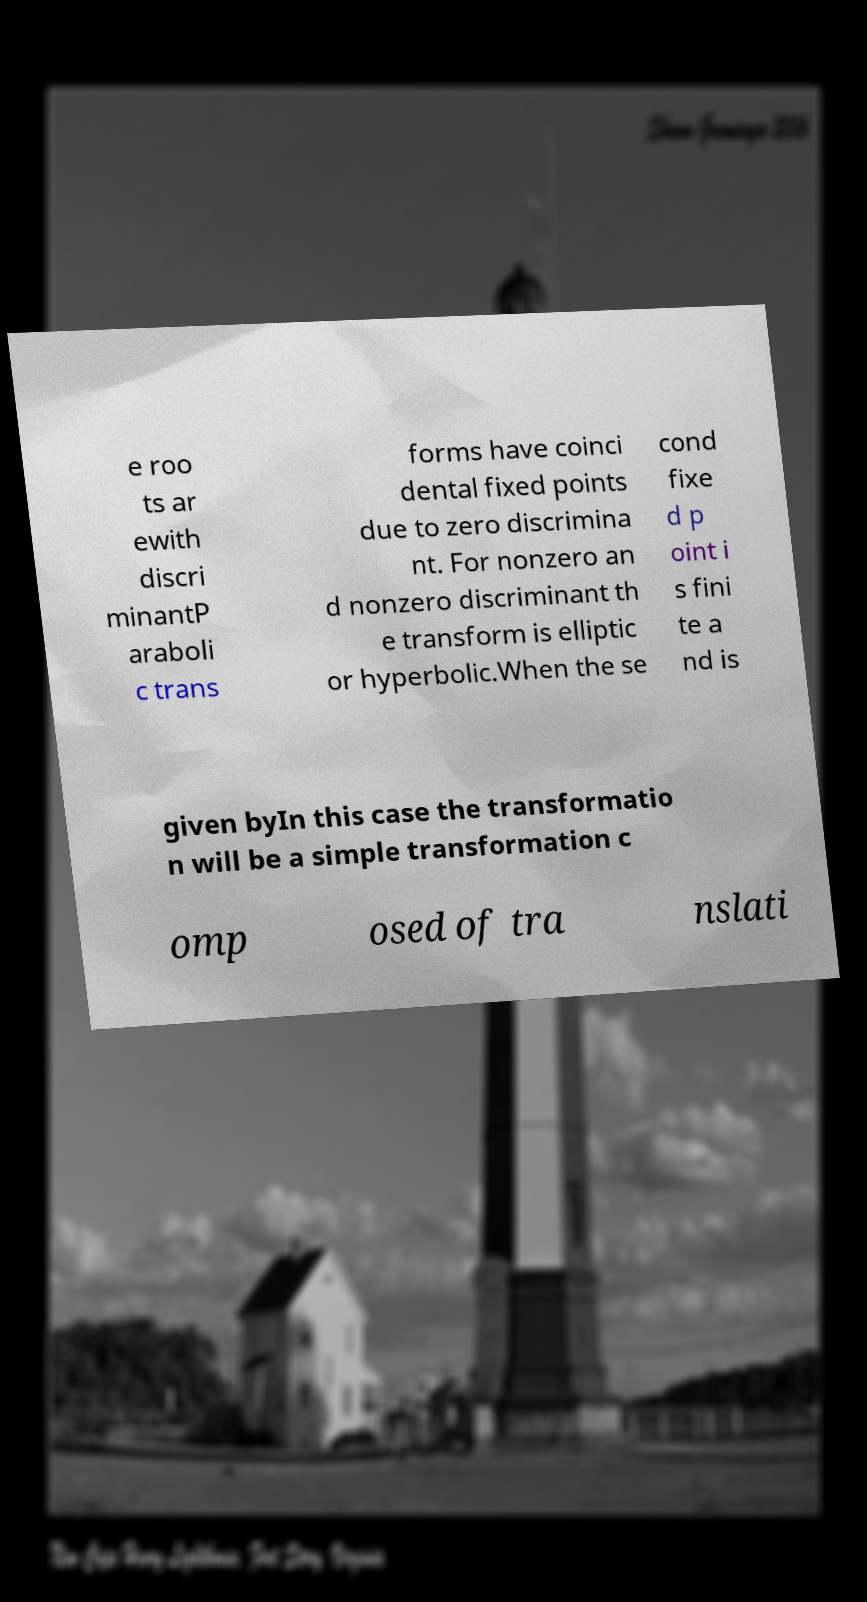Can you accurately transcribe the text from the provided image for me? e roo ts ar ewith discri minantP araboli c trans forms have coinci dental fixed points due to zero discrimina nt. For nonzero an d nonzero discriminant th e transform is elliptic or hyperbolic.When the se cond fixe d p oint i s fini te a nd is given byIn this case the transformatio n will be a simple transformation c omp osed of tra nslati 